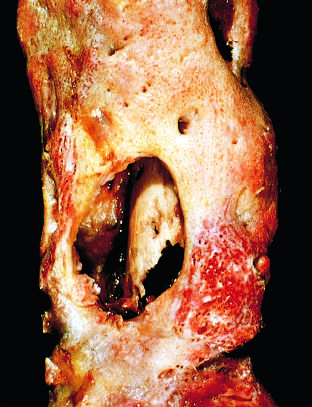what shows the inner native necrotic cortex (sequestrum)?
Answer the question using a single word or phrase. The drainage tract in the subperiosteal shell of viable new bone 